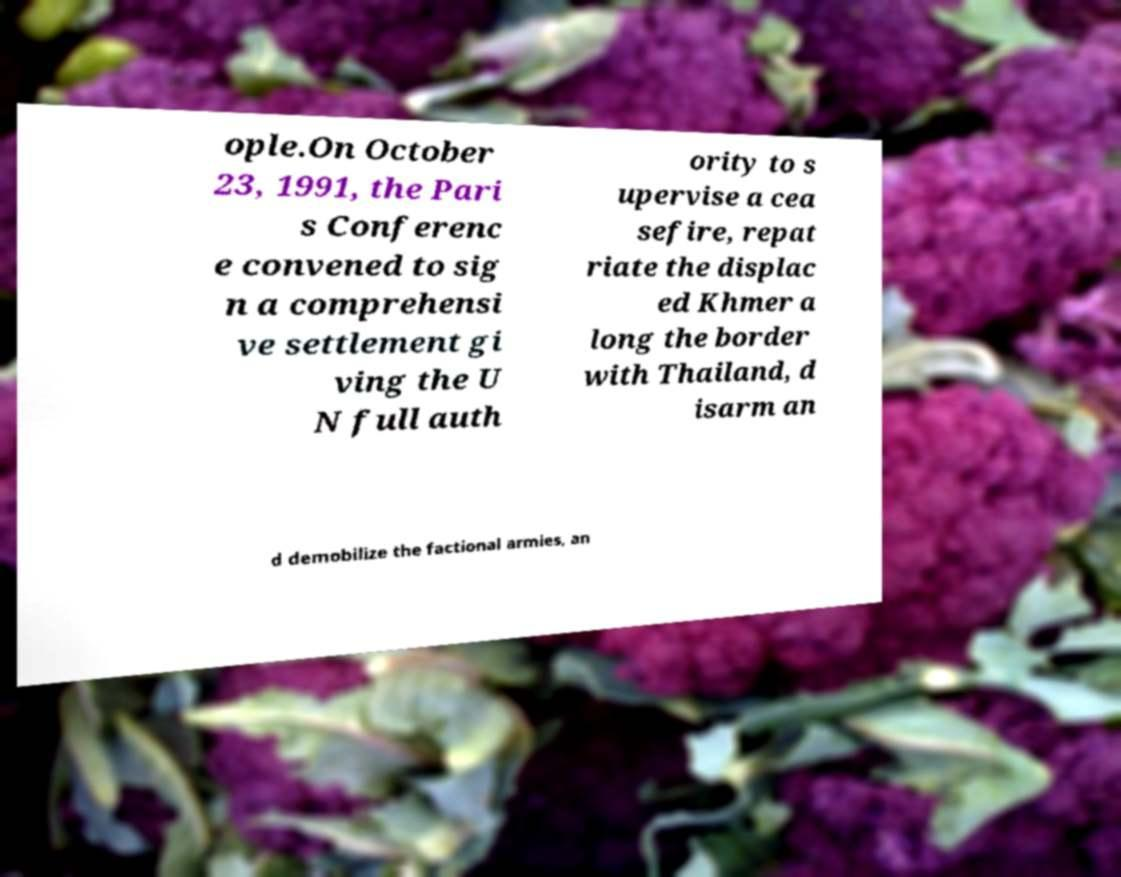Can you read and provide the text displayed in the image?This photo seems to have some interesting text. Can you extract and type it out for me? ople.On October 23, 1991, the Pari s Conferenc e convened to sig n a comprehensi ve settlement gi ving the U N full auth ority to s upervise a cea sefire, repat riate the displac ed Khmer a long the border with Thailand, d isarm an d demobilize the factional armies, an 